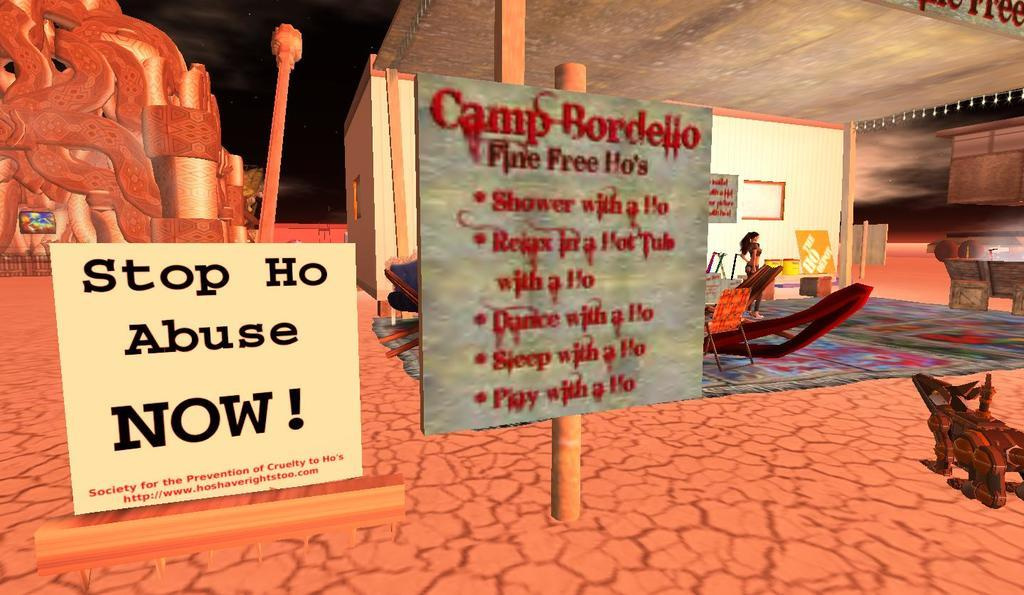Provide a one-sentence caption for the provided image. A sign erected in a virtual world setting for a place called Camp Bordello. 